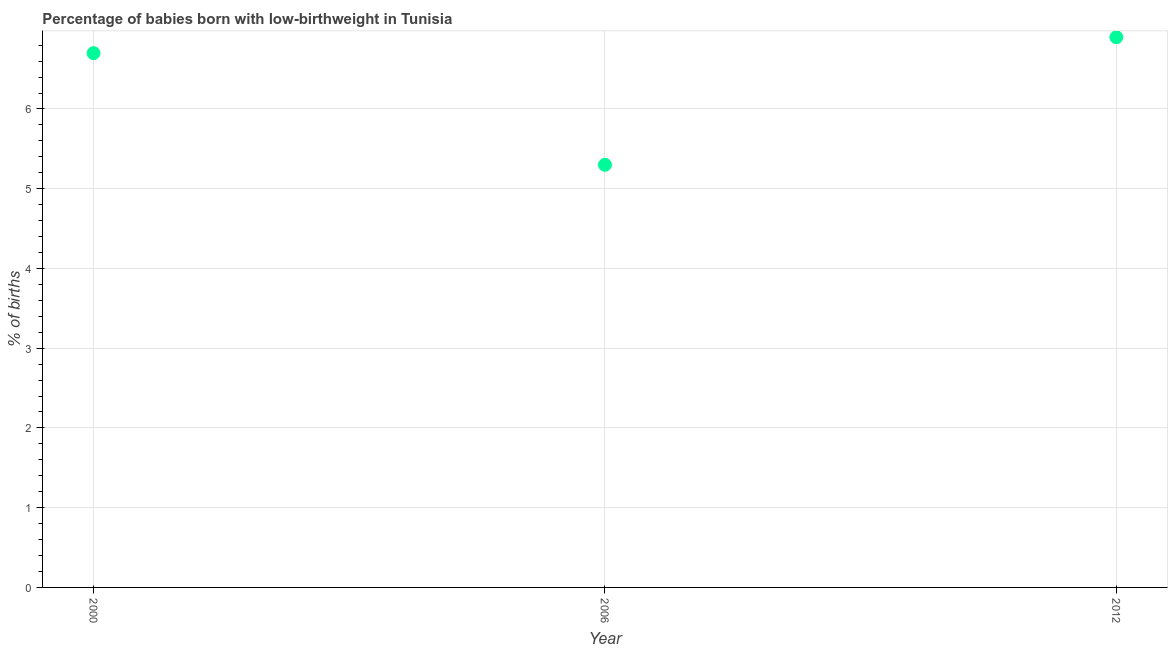In which year was the percentage of babies who were born with low-birthweight minimum?
Offer a terse response. 2006. What is the sum of the percentage of babies who were born with low-birthweight?
Provide a short and direct response. 18.9. What is the difference between the percentage of babies who were born with low-birthweight in 2006 and 2012?
Offer a terse response. -1.6. What is the average percentage of babies who were born with low-birthweight per year?
Offer a very short reply. 6.3. In how many years, is the percentage of babies who were born with low-birthweight greater than 3 %?
Ensure brevity in your answer.  3. Do a majority of the years between 2000 and 2006 (inclusive) have percentage of babies who were born with low-birthweight greater than 6 %?
Offer a very short reply. No. What is the ratio of the percentage of babies who were born with low-birthweight in 2000 to that in 2006?
Your response must be concise. 1.26. Is the percentage of babies who were born with low-birthweight in 2000 less than that in 2006?
Provide a succinct answer. No. What is the difference between the highest and the second highest percentage of babies who were born with low-birthweight?
Your answer should be compact. 0.2. What is the difference between the highest and the lowest percentage of babies who were born with low-birthweight?
Offer a terse response. 1.6. In how many years, is the percentage of babies who were born with low-birthweight greater than the average percentage of babies who were born with low-birthweight taken over all years?
Provide a short and direct response. 2. Does the percentage of babies who were born with low-birthweight monotonically increase over the years?
Ensure brevity in your answer.  No. How many years are there in the graph?
Provide a succinct answer. 3. What is the difference between two consecutive major ticks on the Y-axis?
Your response must be concise. 1. What is the title of the graph?
Your answer should be very brief. Percentage of babies born with low-birthweight in Tunisia. What is the label or title of the Y-axis?
Ensure brevity in your answer.  % of births. What is the % of births in 2000?
Provide a short and direct response. 6.7. What is the % of births in 2006?
Your response must be concise. 5.3. What is the % of births in 2012?
Provide a succinct answer. 6.9. What is the difference between the % of births in 2000 and 2006?
Give a very brief answer. 1.4. What is the difference between the % of births in 2000 and 2012?
Provide a succinct answer. -0.2. What is the ratio of the % of births in 2000 to that in 2006?
Make the answer very short. 1.26. What is the ratio of the % of births in 2006 to that in 2012?
Your response must be concise. 0.77. 